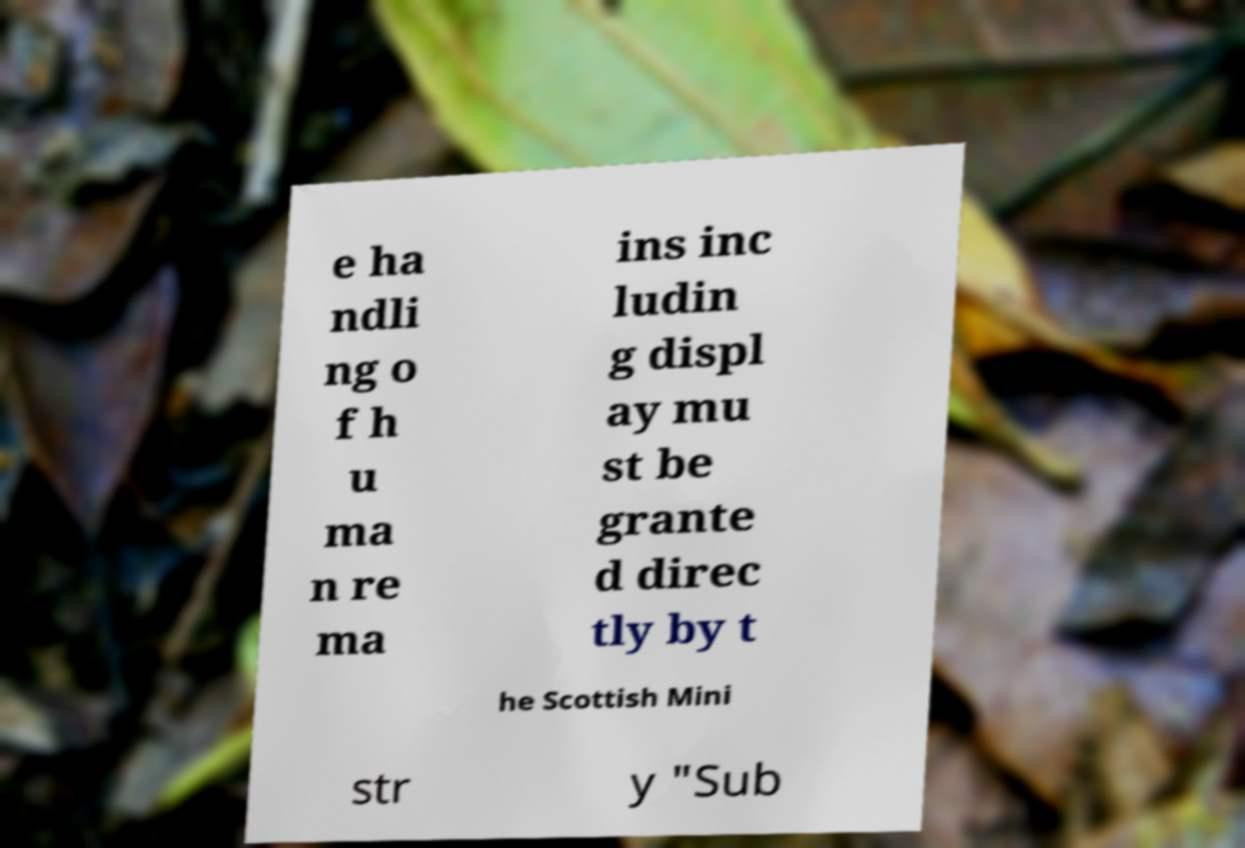Could you assist in decoding the text presented in this image and type it out clearly? e ha ndli ng o f h u ma n re ma ins inc ludin g displ ay mu st be grante d direc tly by t he Scottish Mini str y "Sub 